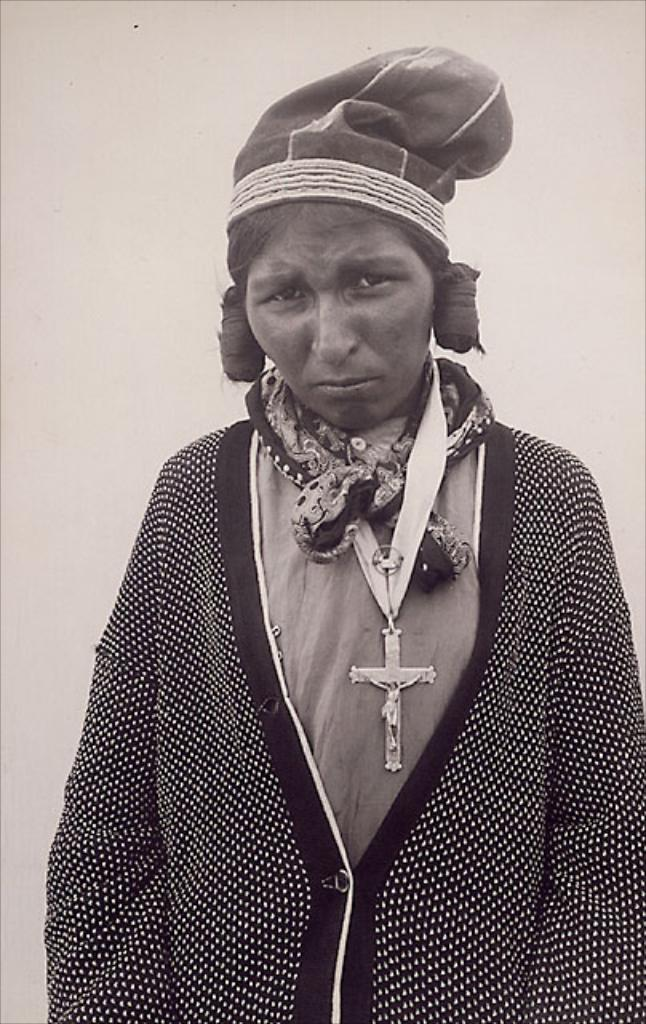Who is present in the image? There is a woman in the image. What is the woman doing in the image? The woman is standing. What type of cave can be seen in the background of the image? There is no cave present in the image; it only features a woman standing. 